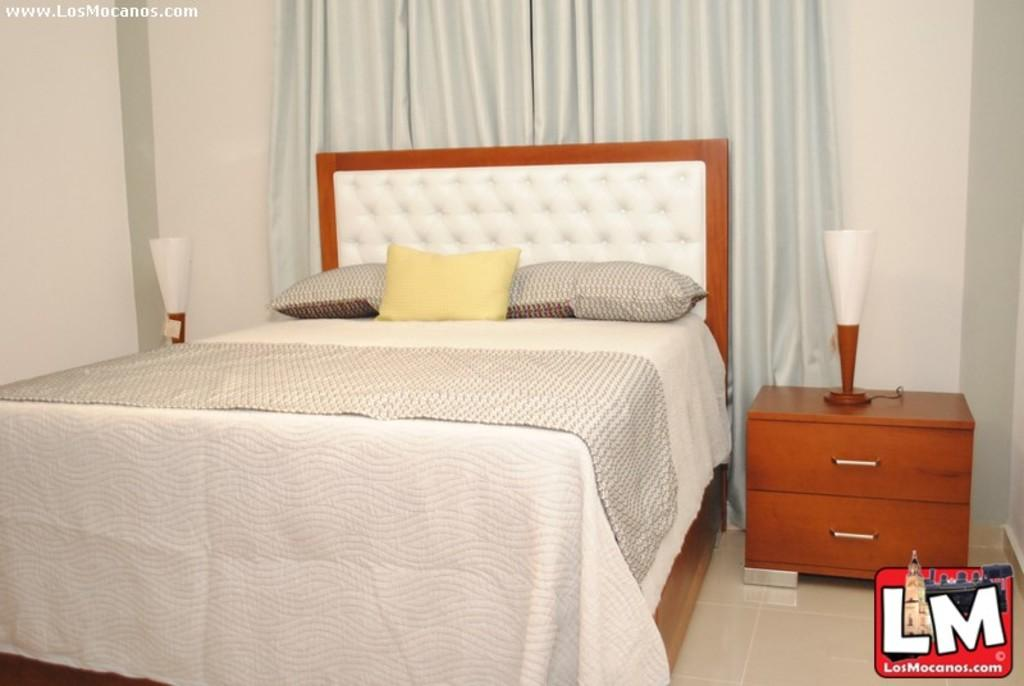What is the main piece of furniture in the center of the image? There is a bed in the center of the image. What is placed on the bed? There are pillows on the bed. What type of window treatment is visible in the image? There is a curtain in the image. What other piece of furniture can be seen in the image? There is a wooden table in the image. What is on top of the wooden table? A table lamp is present on the wooden table. What type of fruit is being gripped by the person in the image? There is no person present in the image, and therefore no fruit can be gripped. What is the person's desire in the image? There is no person present in the image, so it is impossible to determine their desires. 